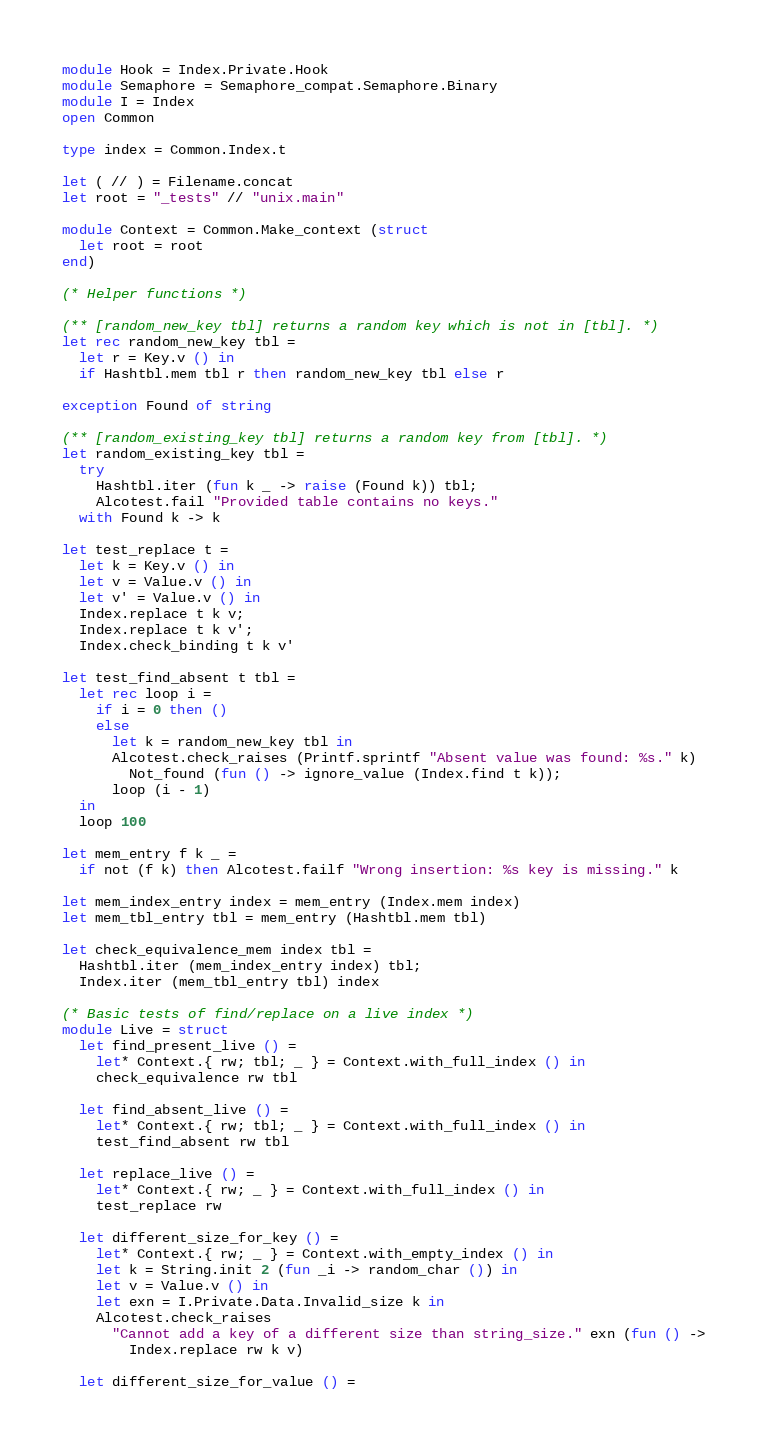Convert code to text. <code><loc_0><loc_0><loc_500><loc_500><_OCaml_>module Hook = Index.Private.Hook
module Semaphore = Semaphore_compat.Semaphore.Binary
module I = Index
open Common

type index = Common.Index.t

let ( // ) = Filename.concat
let root = "_tests" // "unix.main"

module Context = Common.Make_context (struct
  let root = root
end)

(* Helper functions *)

(** [random_new_key tbl] returns a random key which is not in [tbl]. *)
let rec random_new_key tbl =
  let r = Key.v () in
  if Hashtbl.mem tbl r then random_new_key tbl else r

exception Found of string

(** [random_existing_key tbl] returns a random key from [tbl]. *)
let random_existing_key tbl =
  try
    Hashtbl.iter (fun k _ -> raise (Found k)) tbl;
    Alcotest.fail "Provided table contains no keys."
  with Found k -> k

let test_replace t =
  let k = Key.v () in
  let v = Value.v () in
  let v' = Value.v () in
  Index.replace t k v;
  Index.replace t k v';
  Index.check_binding t k v'

let test_find_absent t tbl =
  let rec loop i =
    if i = 0 then ()
    else
      let k = random_new_key tbl in
      Alcotest.check_raises (Printf.sprintf "Absent value was found: %s." k)
        Not_found (fun () -> ignore_value (Index.find t k));
      loop (i - 1)
  in
  loop 100

let mem_entry f k _ =
  if not (f k) then Alcotest.failf "Wrong insertion: %s key is missing." k

let mem_index_entry index = mem_entry (Index.mem index)
let mem_tbl_entry tbl = mem_entry (Hashtbl.mem tbl)

let check_equivalence_mem index tbl =
  Hashtbl.iter (mem_index_entry index) tbl;
  Index.iter (mem_tbl_entry tbl) index

(* Basic tests of find/replace on a live index *)
module Live = struct
  let find_present_live () =
    let* Context.{ rw; tbl; _ } = Context.with_full_index () in
    check_equivalence rw tbl

  let find_absent_live () =
    let* Context.{ rw; tbl; _ } = Context.with_full_index () in
    test_find_absent rw tbl

  let replace_live () =
    let* Context.{ rw; _ } = Context.with_full_index () in
    test_replace rw

  let different_size_for_key () =
    let* Context.{ rw; _ } = Context.with_empty_index () in
    let k = String.init 2 (fun _i -> random_char ()) in
    let v = Value.v () in
    let exn = I.Private.Data.Invalid_size k in
    Alcotest.check_raises
      "Cannot add a key of a different size than string_size." exn (fun () ->
        Index.replace rw k v)

  let different_size_for_value () =</code> 